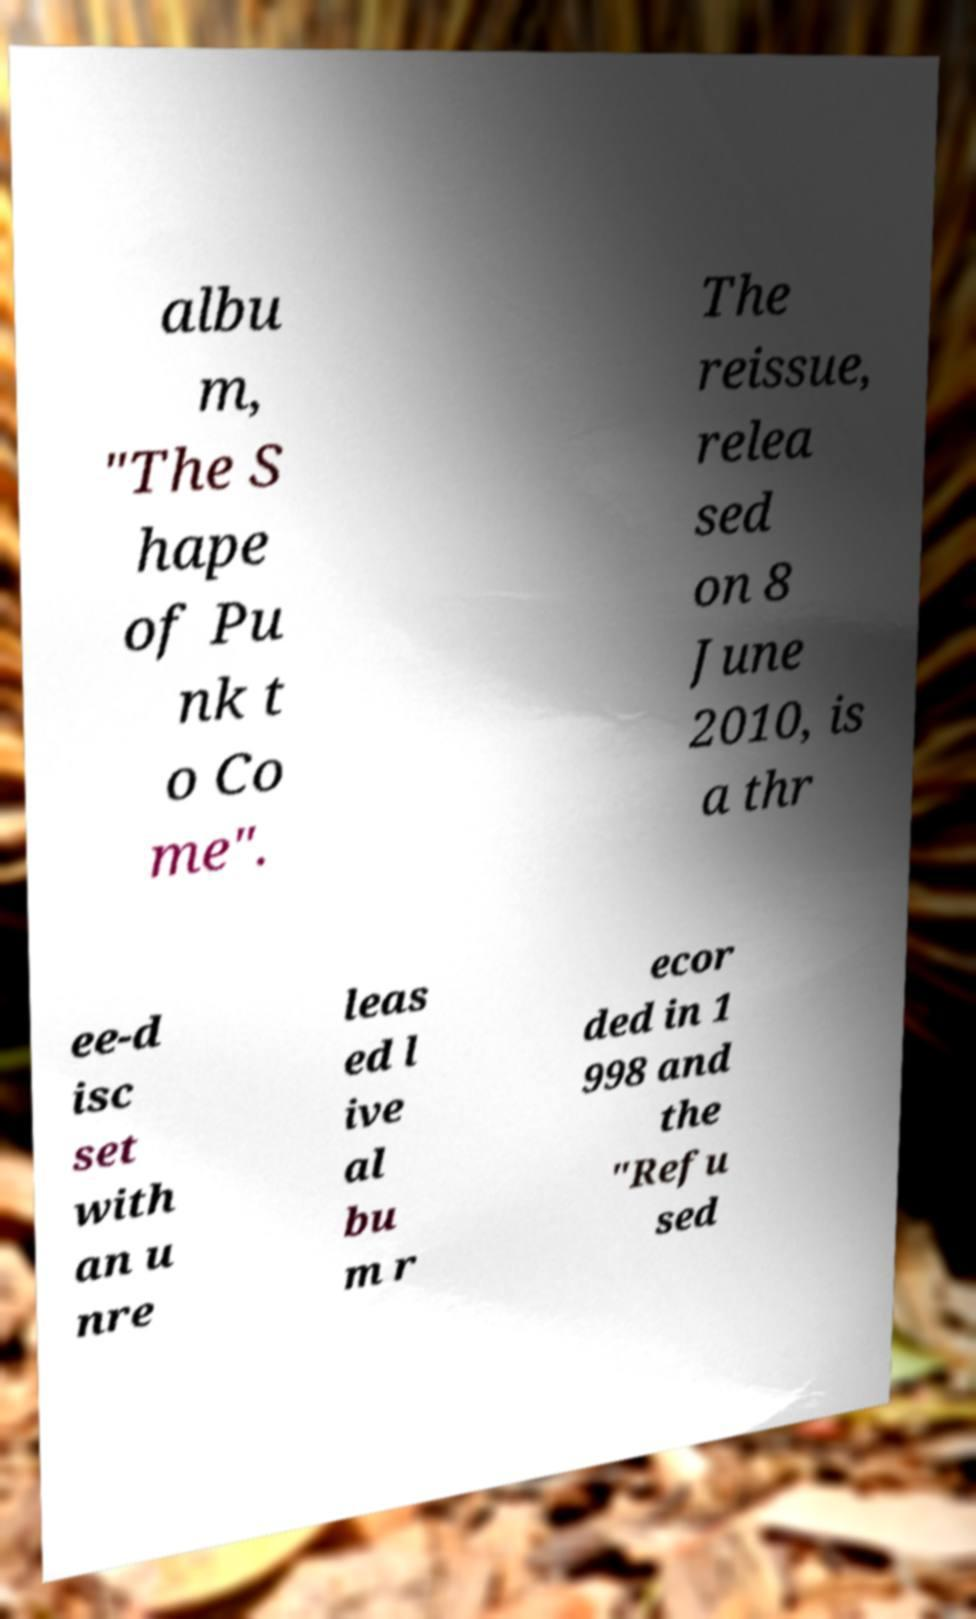What messages or text are displayed in this image? I need them in a readable, typed format. albu m, "The S hape of Pu nk t o Co me". The reissue, relea sed on 8 June 2010, is a thr ee-d isc set with an u nre leas ed l ive al bu m r ecor ded in 1 998 and the "Refu sed 